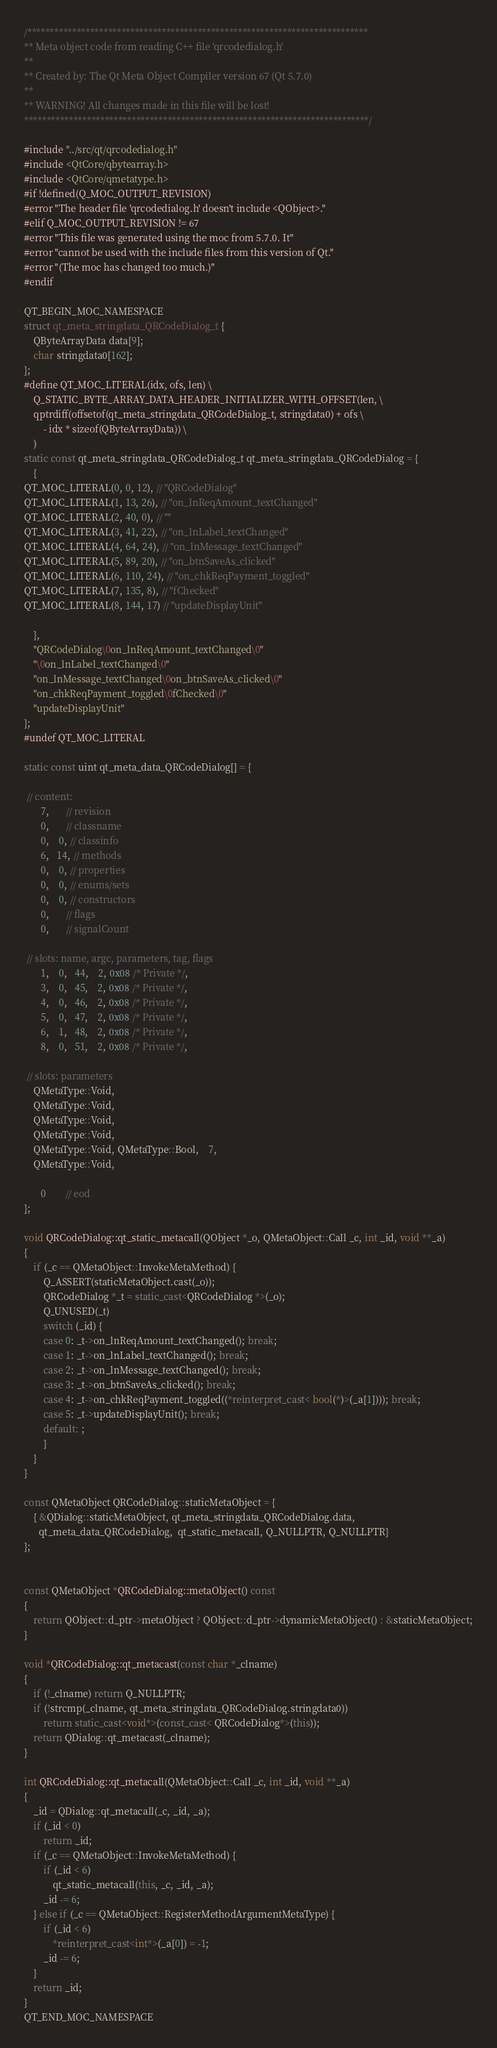<code> <loc_0><loc_0><loc_500><loc_500><_C++_>/****************************************************************************
** Meta object code from reading C++ file 'qrcodedialog.h'
**
** Created by: The Qt Meta Object Compiler version 67 (Qt 5.7.0)
**
** WARNING! All changes made in this file will be lost!
*****************************************************************************/

#include "../src/qt/qrcodedialog.h"
#include <QtCore/qbytearray.h>
#include <QtCore/qmetatype.h>
#if !defined(Q_MOC_OUTPUT_REVISION)
#error "The header file 'qrcodedialog.h' doesn't include <QObject>."
#elif Q_MOC_OUTPUT_REVISION != 67
#error "This file was generated using the moc from 5.7.0. It"
#error "cannot be used with the include files from this version of Qt."
#error "(The moc has changed too much.)"
#endif

QT_BEGIN_MOC_NAMESPACE
struct qt_meta_stringdata_QRCodeDialog_t {
    QByteArrayData data[9];
    char stringdata0[162];
};
#define QT_MOC_LITERAL(idx, ofs, len) \
    Q_STATIC_BYTE_ARRAY_DATA_HEADER_INITIALIZER_WITH_OFFSET(len, \
    qptrdiff(offsetof(qt_meta_stringdata_QRCodeDialog_t, stringdata0) + ofs \
        - idx * sizeof(QByteArrayData)) \
    )
static const qt_meta_stringdata_QRCodeDialog_t qt_meta_stringdata_QRCodeDialog = {
    {
QT_MOC_LITERAL(0, 0, 12), // "QRCodeDialog"
QT_MOC_LITERAL(1, 13, 26), // "on_lnReqAmount_textChanged"
QT_MOC_LITERAL(2, 40, 0), // ""
QT_MOC_LITERAL(3, 41, 22), // "on_lnLabel_textChanged"
QT_MOC_LITERAL(4, 64, 24), // "on_lnMessage_textChanged"
QT_MOC_LITERAL(5, 89, 20), // "on_btnSaveAs_clicked"
QT_MOC_LITERAL(6, 110, 24), // "on_chkReqPayment_toggled"
QT_MOC_LITERAL(7, 135, 8), // "fChecked"
QT_MOC_LITERAL(8, 144, 17) // "updateDisplayUnit"

    },
    "QRCodeDialog\0on_lnReqAmount_textChanged\0"
    "\0on_lnLabel_textChanged\0"
    "on_lnMessage_textChanged\0on_btnSaveAs_clicked\0"
    "on_chkReqPayment_toggled\0fChecked\0"
    "updateDisplayUnit"
};
#undef QT_MOC_LITERAL

static const uint qt_meta_data_QRCodeDialog[] = {

 // content:
       7,       // revision
       0,       // classname
       0,    0, // classinfo
       6,   14, // methods
       0,    0, // properties
       0,    0, // enums/sets
       0,    0, // constructors
       0,       // flags
       0,       // signalCount

 // slots: name, argc, parameters, tag, flags
       1,    0,   44,    2, 0x08 /* Private */,
       3,    0,   45,    2, 0x08 /* Private */,
       4,    0,   46,    2, 0x08 /* Private */,
       5,    0,   47,    2, 0x08 /* Private */,
       6,    1,   48,    2, 0x08 /* Private */,
       8,    0,   51,    2, 0x08 /* Private */,

 // slots: parameters
    QMetaType::Void,
    QMetaType::Void,
    QMetaType::Void,
    QMetaType::Void,
    QMetaType::Void, QMetaType::Bool,    7,
    QMetaType::Void,

       0        // eod
};

void QRCodeDialog::qt_static_metacall(QObject *_o, QMetaObject::Call _c, int _id, void **_a)
{
    if (_c == QMetaObject::InvokeMetaMethod) {
        Q_ASSERT(staticMetaObject.cast(_o));
        QRCodeDialog *_t = static_cast<QRCodeDialog *>(_o);
        Q_UNUSED(_t)
        switch (_id) {
        case 0: _t->on_lnReqAmount_textChanged(); break;
        case 1: _t->on_lnLabel_textChanged(); break;
        case 2: _t->on_lnMessage_textChanged(); break;
        case 3: _t->on_btnSaveAs_clicked(); break;
        case 4: _t->on_chkReqPayment_toggled((*reinterpret_cast< bool(*)>(_a[1]))); break;
        case 5: _t->updateDisplayUnit(); break;
        default: ;
        }
    }
}

const QMetaObject QRCodeDialog::staticMetaObject = {
    { &QDialog::staticMetaObject, qt_meta_stringdata_QRCodeDialog.data,
      qt_meta_data_QRCodeDialog,  qt_static_metacall, Q_NULLPTR, Q_NULLPTR}
};


const QMetaObject *QRCodeDialog::metaObject() const
{
    return QObject::d_ptr->metaObject ? QObject::d_ptr->dynamicMetaObject() : &staticMetaObject;
}

void *QRCodeDialog::qt_metacast(const char *_clname)
{
    if (!_clname) return Q_NULLPTR;
    if (!strcmp(_clname, qt_meta_stringdata_QRCodeDialog.stringdata0))
        return static_cast<void*>(const_cast< QRCodeDialog*>(this));
    return QDialog::qt_metacast(_clname);
}

int QRCodeDialog::qt_metacall(QMetaObject::Call _c, int _id, void **_a)
{
    _id = QDialog::qt_metacall(_c, _id, _a);
    if (_id < 0)
        return _id;
    if (_c == QMetaObject::InvokeMetaMethod) {
        if (_id < 6)
            qt_static_metacall(this, _c, _id, _a);
        _id -= 6;
    } else if (_c == QMetaObject::RegisterMethodArgumentMetaType) {
        if (_id < 6)
            *reinterpret_cast<int*>(_a[0]) = -1;
        _id -= 6;
    }
    return _id;
}
QT_END_MOC_NAMESPACE
</code> 